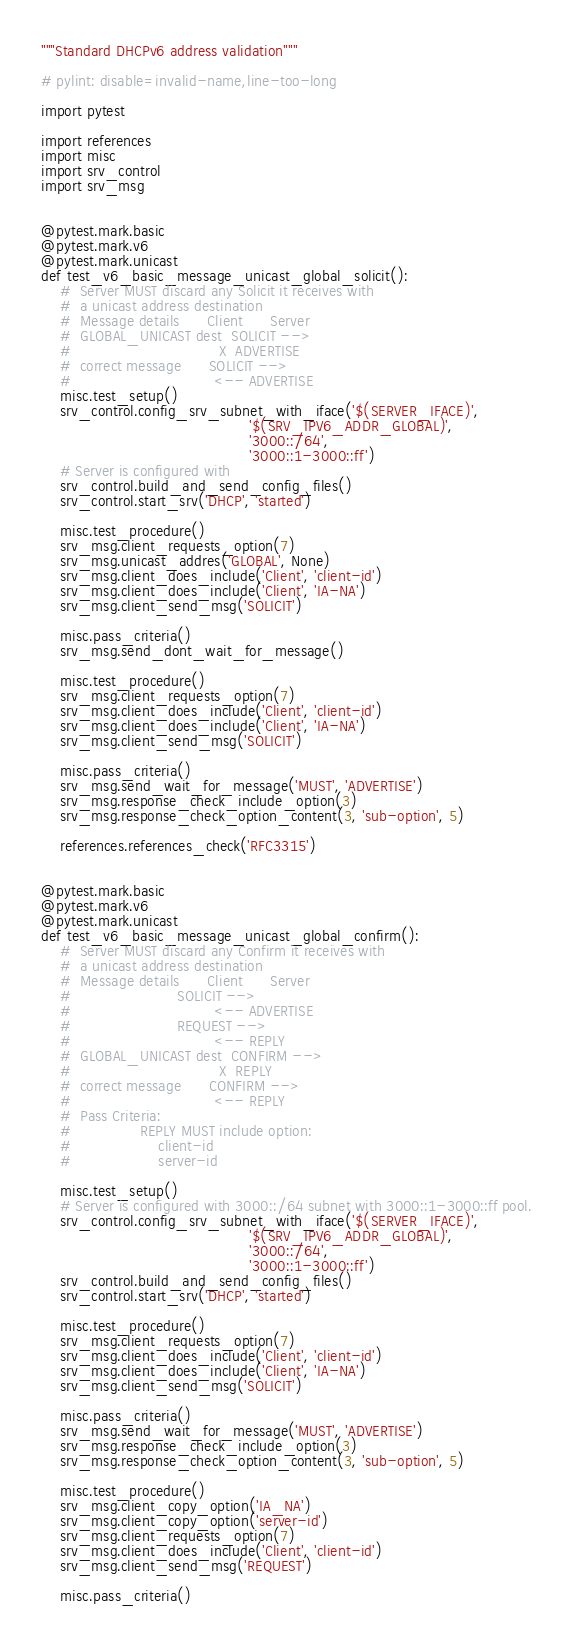Convert code to text. <code><loc_0><loc_0><loc_500><loc_500><_Python_>"""Standard DHCPv6 address validation"""

# pylint: disable=invalid-name,line-too-long

import pytest

import references
import misc
import srv_control
import srv_msg


@pytest.mark.basic
@pytest.mark.v6
@pytest.mark.unicast
def test_v6_basic_message_unicast_global_solicit():
    #  Server MUST discard any Solicit it receives with
    #  a unicast address destination
    #  Message details 		Client		Server
    #  GLOBAL_UNICAST dest  SOLICIT -->
    #  		   						 X	ADVERTISE
    #  correct message		SOLICIT -->
    #  		   						<--	ADVERTISE
    misc.test_setup()
    srv_control.config_srv_subnet_with_iface('$(SERVER_IFACE)',
                                             '$(SRV_IPV6_ADDR_GLOBAL)',
                                             '3000::/64',
                                             '3000::1-3000::ff')
    # Server is configured with
    srv_control.build_and_send_config_files()
    srv_control.start_srv('DHCP', 'started')

    misc.test_procedure()
    srv_msg.client_requests_option(7)
    srv_msg.unicast_addres('GLOBAL', None)
    srv_msg.client_does_include('Client', 'client-id')
    srv_msg.client_does_include('Client', 'IA-NA')
    srv_msg.client_send_msg('SOLICIT')

    misc.pass_criteria()
    srv_msg.send_dont_wait_for_message()

    misc.test_procedure()
    srv_msg.client_requests_option(7)
    srv_msg.client_does_include('Client', 'client-id')
    srv_msg.client_does_include('Client', 'IA-NA')
    srv_msg.client_send_msg('SOLICIT')

    misc.pass_criteria()
    srv_msg.send_wait_for_message('MUST', 'ADVERTISE')
    srv_msg.response_check_include_option(3)
    srv_msg.response_check_option_content(3, 'sub-option', 5)

    references.references_check('RFC3315')


@pytest.mark.basic
@pytest.mark.v6
@pytest.mark.unicast
def test_v6_basic_message_unicast_global_confirm():
    #  Server MUST discard any Confirm it receives with
    #  a unicast address destination
    #  Message details 		Client		Server
    #  						SOLICIT -->
    #  		   						<--	ADVERTISE
    #  						REQUEST -->
    #  		   						<--	REPLY
    #  GLOBAL_UNICAST dest	CONFIRM -->
    # 					  		     X	REPLY
    #  correct message 		CONFIRM -->
    # 					  		    <--	REPLY
    #  Pass Criteria:
    #  				REPLY MUST include option:
    # 					client-id
    # 					server-id

    misc.test_setup()
    # Server is configured with 3000::/64 subnet with 3000::1-3000::ff pool.
    srv_control.config_srv_subnet_with_iface('$(SERVER_IFACE)',
                                             '$(SRV_IPV6_ADDR_GLOBAL)',
                                             '3000::/64',
                                             '3000::1-3000::ff')
    srv_control.build_and_send_config_files()
    srv_control.start_srv('DHCP', 'started')

    misc.test_procedure()
    srv_msg.client_requests_option(7)
    srv_msg.client_does_include('Client', 'client-id')
    srv_msg.client_does_include('Client', 'IA-NA')
    srv_msg.client_send_msg('SOLICIT')

    misc.pass_criteria()
    srv_msg.send_wait_for_message('MUST', 'ADVERTISE')
    srv_msg.response_check_include_option(3)
    srv_msg.response_check_option_content(3, 'sub-option', 5)

    misc.test_procedure()
    srv_msg.client_copy_option('IA_NA')
    srv_msg.client_copy_option('server-id')
    srv_msg.client_requests_option(7)
    srv_msg.client_does_include('Client', 'client-id')
    srv_msg.client_send_msg('REQUEST')

    misc.pass_criteria()</code> 